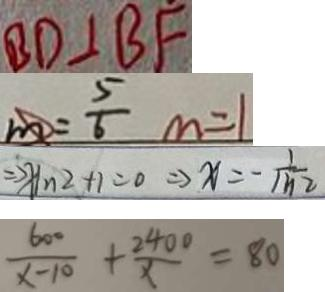Convert formula to latex. <formula><loc_0><loc_0><loc_500><loc_500>B D \bot B F 
 m = \frac { 5 } { 6 } m = 1 
 \Rightarrow X I n ^ { 2 } + 1 = 0 \Rightarrow x = - \frac { 1 } { m 2 } 
 \frac { 6 0 0 } { x - 1 0 } + \frac { 2 4 0 0 } { x } = 8 0</formula> 